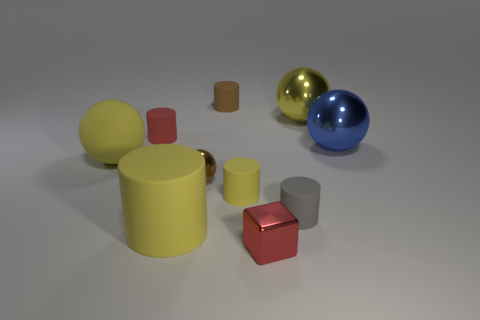Subtract all gray cylinders. How many cylinders are left? 4 Subtract all tiny yellow matte cylinders. How many cylinders are left? 4 Subtract all green cylinders. Subtract all green cubes. How many cylinders are left? 5 Subtract all balls. How many objects are left? 6 Add 2 large yellow things. How many large yellow things exist? 5 Subtract 1 red cubes. How many objects are left? 9 Subtract all tiny red objects. Subtract all rubber balls. How many objects are left? 7 Add 3 large blue balls. How many large blue balls are left? 4 